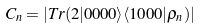<formula> <loc_0><loc_0><loc_500><loc_500>C _ { n } = | T r ( 2 | 0 0 0 0 \rangle \langle 1 0 0 0 | \rho _ { n } ) |</formula> 